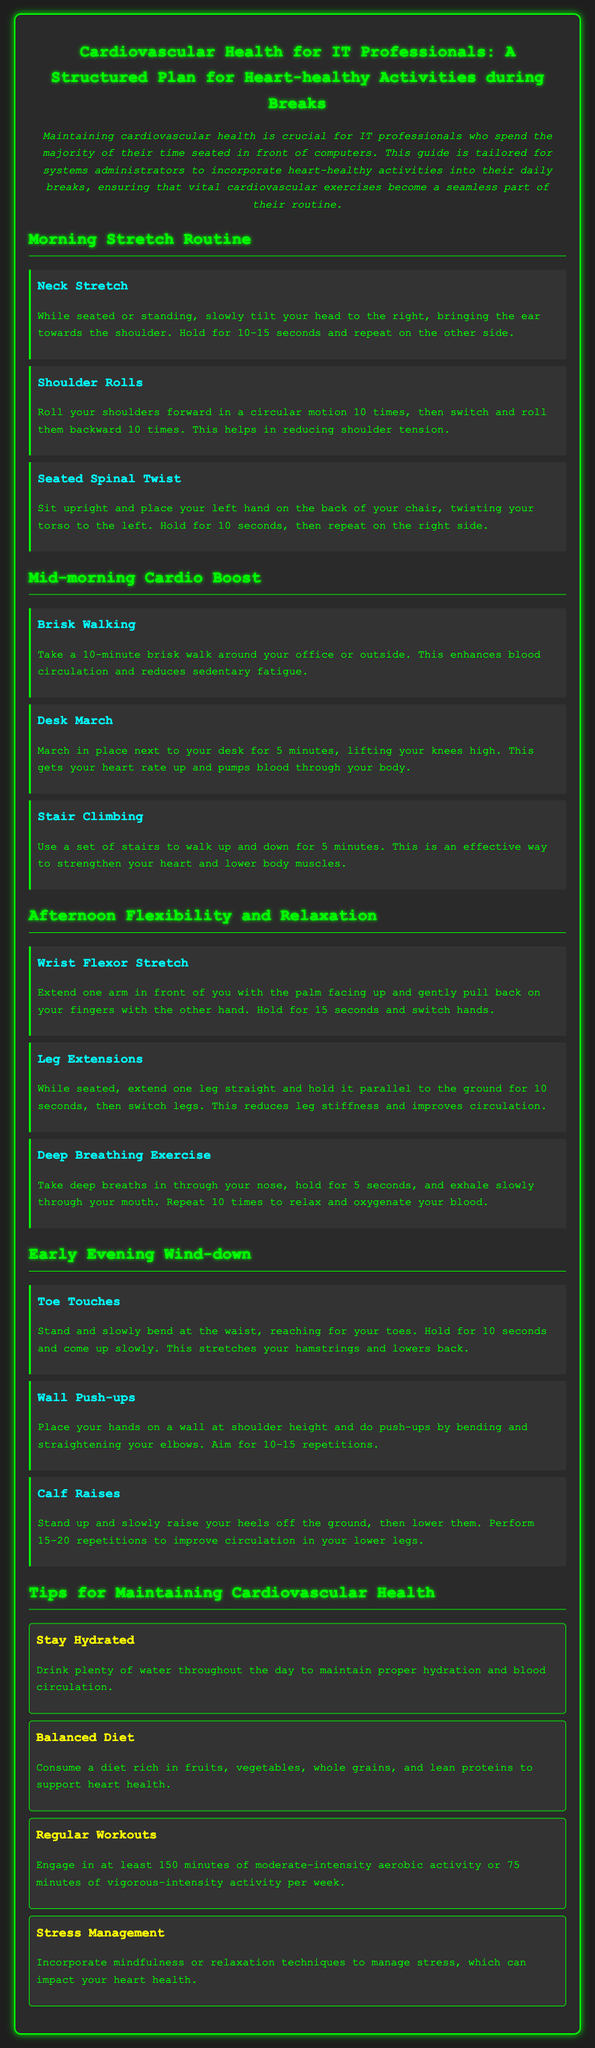What is the title of the document? The title of the document is the main heading at the top, indicating its focus on cardiovascular health for IT professionals.
Answer: Cardiovascular Health for IT Professionals: A Structured Plan for Heart-healthy Activities during Breaks How long should the brisk walking activity last? The brisk walking activity specifies a duration meant to enhance blood circulation and reduce sedentary fatigue, which is mentioned in its description.
Answer: 10 minutes How many repetitions are suggested for wall push-ups? The wall push-ups activity describes the recommended number of repetitions to perform for effective exercise, noted in the instructions.
Answer: 10-15 What is one tip for maintaining cardiovascular health? The tips section provides several suggestions, each highlighting different aspects of cardiovascular health, and the answer can be taken from the listed tips.
Answer: Stay Hydrated What is the purpose of the deep breathing exercise? The deep breathing exercise details the intended outcome of the activity, which focuses on relaxation and oxygenation of blood, as mentioned in the description.
Answer: Relax and oxygenate your blood What activity involves lifting your knees high? This activity is mentioned in the mid-morning cardio boost section, specifying the action to elevate heart rate.
Answer: Desk March Which activity aims to reduce leg stiffness? The activity focuses on leg flexibility and circulation improvement as described in the afternoon section.
Answer: Leg Extensions What dietary suggestion is given for heart health? The balanced diet tip provides guidance on nutritional choices beneficial for cardiovascular health, indicating specific food types.
Answer: Fruits, vegetables, whole grains, and lean proteins 